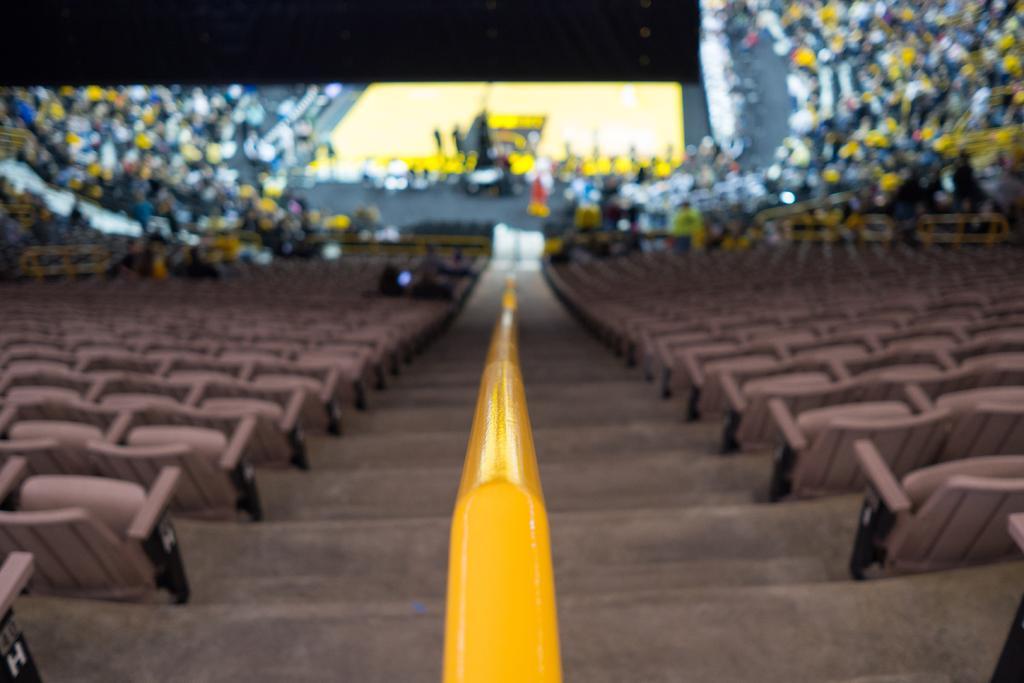Can you describe this image briefly? This image is a picture of a stadium as we can see there are some chairs at left side of this image and right side of this image as well, and there are some audience sitting at top of this image and there is a ground in top middle of this image. 